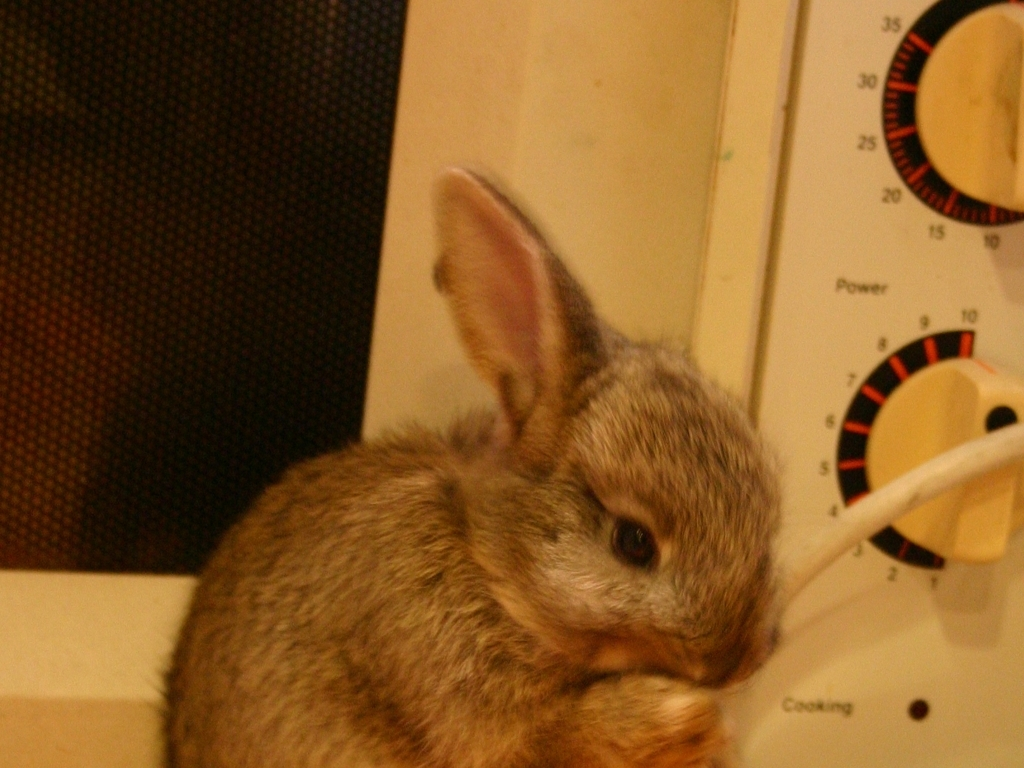What sort of environment is the rabbit in? This rabbit is in a domestic setting, likely inside a home. It's near a household appliance, which suggests that the rabbit is a pet and is comfortable in human living spaces. Is this a safe activity for the rabbit? No, it's not safe for the rabbit to chew on or be near electrical cords due to the risk of electrical shock or ingesting harmful materials. It would be important for the owner to rabbit-proof the home to prevent such dangers. 